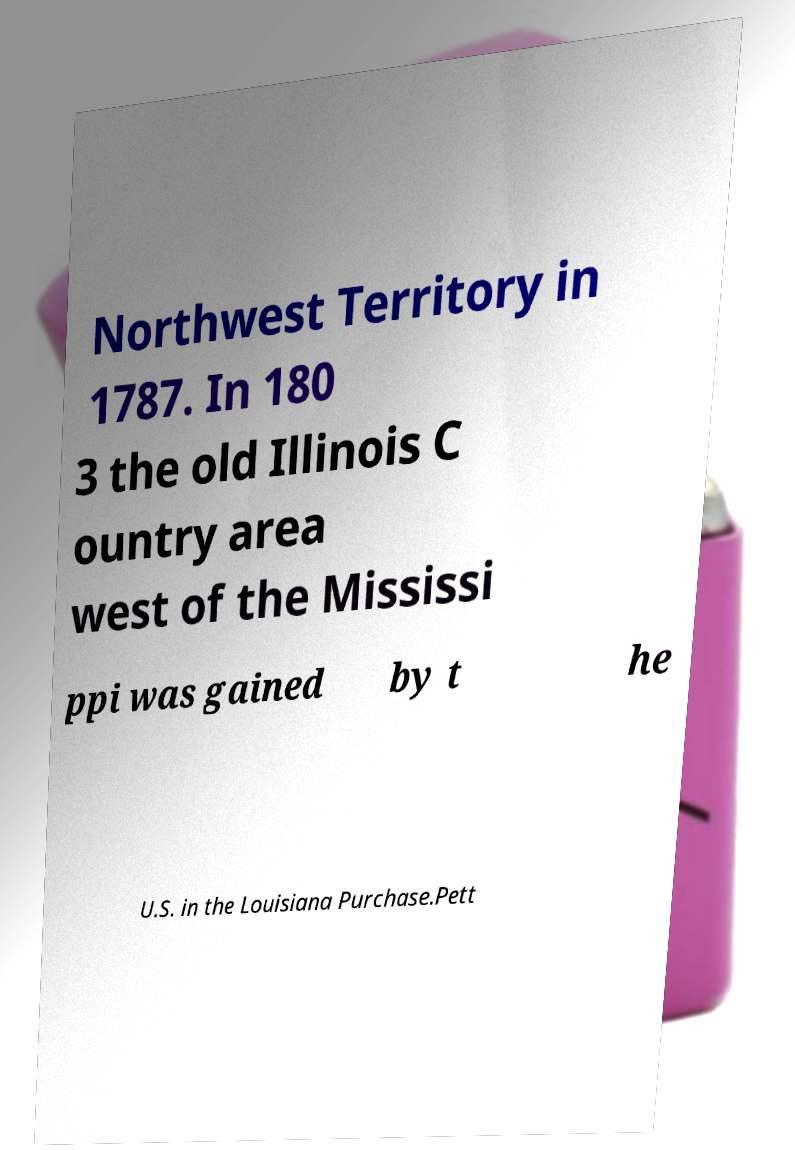I need the written content from this picture converted into text. Can you do that? Northwest Territory in 1787. In 180 3 the old Illinois C ountry area west of the Mississi ppi was gained by t he U.S. in the Louisiana Purchase.Pett 